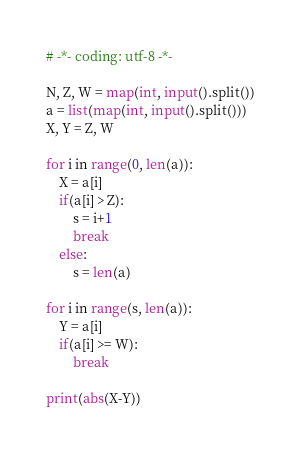<code> <loc_0><loc_0><loc_500><loc_500><_Python_># -*- coding: utf-8 -*-

N, Z, W = map(int, input().split())
a = list(map(int, input().split()))
X, Y = Z, W

for i in range(0, len(a)):
    X = a[i]
    if(a[i] > Z):
        s = i+1
        break
    else:
        s = len(a)

for i in range(s, len(a)):
    Y = a[i]
    if(a[i] >= W):
        break

print(abs(X-Y))
</code> 